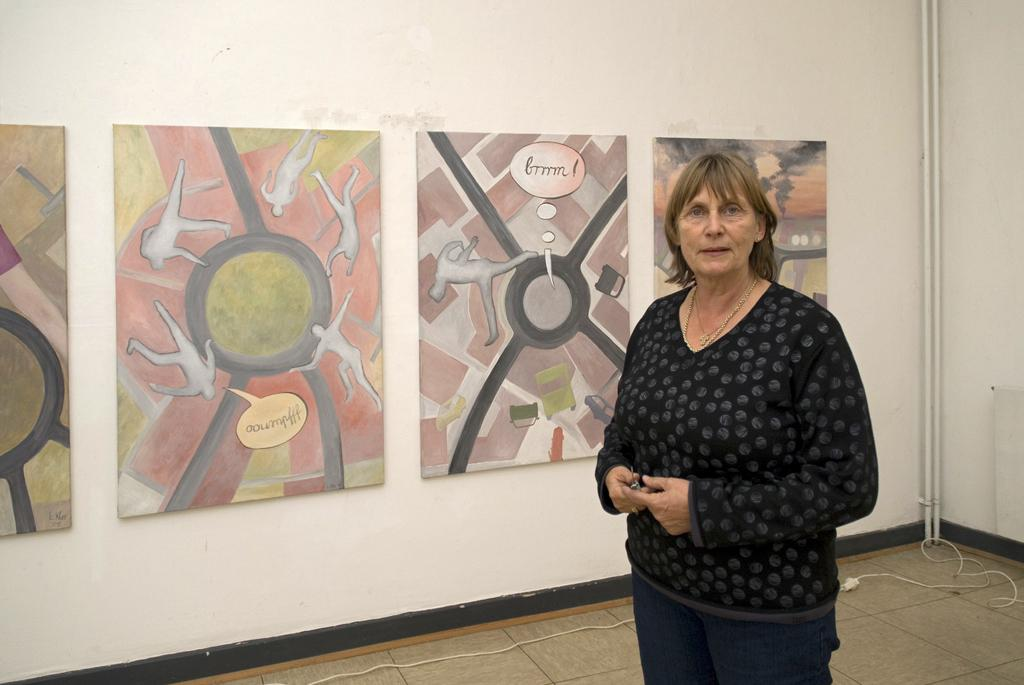What is the woman in the image doing? The woman is standing in the image. What is the woman wearing? The woman is wearing a black top. What can be seen on the wall in the image? There are paintings on the wall in the image. What type of test can be seen being conducted in the image? There is no test being conducted in the image; it only features a woman standing and paintings on the wall. 